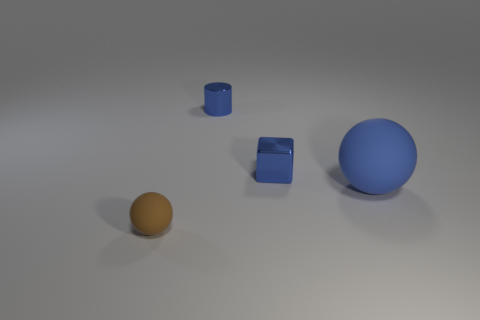Add 3 tiny cylinders. How many objects exist? 7 Subtract all blocks. How many objects are left? 3 Subtract 0 purple spheres. How many objects are left? 4 Subtract all tiny gray cylinders. Subtract all large objects. How many objects are left? 3 Add 2 small metal cylinders. How many small metal cylinders are left? 3 Add 3 big blue rubber spheres. How many big blue rubber spheres exist? 4 